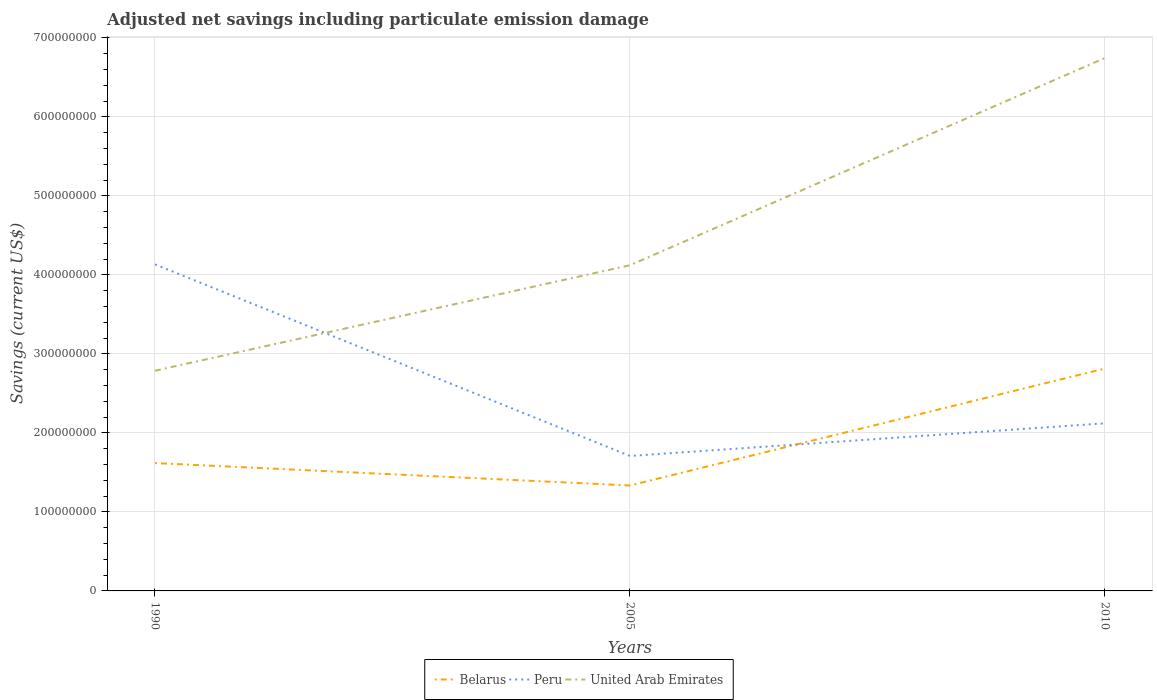How many different coloured lines are there?
Your answer should be compact. 3. Does the line corresponding to United Arab Emirates intersect with the line corresponding to Peru?
Ensure brevity in your answer.  Yes. Across all years, what is the maximum net savings in United Arab Emirates?
Ensure brevity in your answer.  2.79e+08. What is the total net savings in Belarus in the graph?
Offer a very short reply. 2.84e+07. What is the difference between the highest and the second highest net savings in Belarus?
Keep it short and to the point. 1.48e+08. What is the difference between the highest and the lowest net savings in United Arab Emirates?
Your answer should be compact. 1. Is the net savings in Belarus strictly greater than the net savings in Peru over the years?
Your answer should be compact. No. What is the difference between two consecutive major ticks on the Y-axis?
Offer a very short reply. 1.00e+08. Are the values on the major ticks of Y-axis written in scientific E-notation?
Ensure brevity in your answer.  No. Does the graph contain any zero values?
Ensure brevity in your answer.  No. How many legend labels are there?
Give a very brief answer. 3. How are the legend labels stacked?
Offer a very short reply. Horizontal. What is the title of the graph?
Offer a very short reply. Adjusted net savings including particulate emission damage. What is the label or title of the Y-axis?
Give a very brief answer. Savings (current US$). What is the Savings (current US$) in Belarus in 1990?
Your answer should be compact. 1.62e+08. What is the Savings (current US$) in Peru in 1990?
Make the answer very short. 4.13e+08. What is the Savings (current US$) of United Arab Emirates in 1990?
Provide a succinct answer. 2.79e+08. What is the Savings (current US$) in Belarus in 2005?
Ensure brevity in your answer.  1.33e+08. What is the Savings (current US$) in Peru in 2005?
Your response must be concise. 1.71e+08. What is the Savings (current US$) of United Arab Emirates in 2005?
Offer a terse response. 4.12e+08. What is the Savings (current US$) in Belarus in 2010?
Provide a succinct answer. 2.82e+08. What is the Savings (current US$) in Peru in 2010?
Your response must be concise. 2.12e+08. What is the Savings (current US$) in United Arab Emirates in 2010?
Provide a short and direct response. 6.75e+08. Across all years, what is the maximum Savings (current US$) of Belarus?
Ensure brevity in your answer.  2.82e+08. Across all years, what is the maximum Savings (current US$) in Peru?
Make the answer very short. 4.13e+08. Across all years, what is the maximum Savings (current US$) in United Arab Emirates?
Offer a terse response. 6.75e+08. Across all years, what is the minimum Savings (current US$) in Belarus?
Offer a terse response. 1.33e+08. Across all years, what is the minimum Savings (current US$) of Peru?
Your response must be concise. 1.71e+08. Across all years, what is the minimum Savings (current US$) in United Arab Emirates?
Keep it short and to the point. 2.79e+08. What is the total Savings (current US$) in Belarus in the graph?
Make the answer very short. 5.77e+08. What is the total Savings (current US$) of Peru in the graph?
Your response must be concise. 7.96e+08. What is the total Savings (current US$) of United Arab Emirates in the graph?
Offer a terse response. 1.37e+09. What is the difference between the Savings (current US$) in Belarus in 1990 and that in 2005?
Offer a very short reply. 2.84e+07. What is the difference between the Savings (current US$) in Peru in 1990 and that in 2005?
Your response must be concise. 2.43e+08. What is the difference between the Savings (current US$) of United Arab Emirates in 1990 and that in 2005?
Your answer should be very brief. -1.34e+08. What is the difference between the Savings (current US$) in Belarus in 1990 and that in 2010?
Ensure brevity in your answer.  -1.20e+08. What is the difference between the Savings (current US$) in Peru in 1990 and that in 2010?
Your response must be concise. 2.01e+08. What is the difference between the Savings (current US$) of United Arab Emirates in 1990 and that in 2010?
Your answer should be very brief. -3.96e+08. What is the difference between the Savings (current US$) in Belarus in 2005 and that in 2010?
Make the answer very short. -1.48e+08. What is the difference between the Savings (current US$) in Peru in 2005 and that in 2010?
Ensure brevity in your answer.  -4.13e+07. What is the difference between the Savings (current US$) in United Arab Emirates in 2005 and that in 2010?
Offer a very short reply. -2.62e+08. What is the difference between the Savings (current US$) in Belarus in 1990 and the Savings (current US$) in Peru in 2005?
Your answer should be very brief. -9.00e+06. What is the difference between the Savings (current US$) of Belarus in 1990 and the Savings (current US$) of United Arab Emirates in 2005?
Your answer should be compact. -2.50e+08. What is the difference between the Savings (current US$) in Peru in 1990 and the Savings (current US$) in United Arab Emirates in 2005?
Make the answer very short. 1.05e+06. What is the difference between the Savings (current US$) of Belarus in 1990 and the Savings (current US$) of Peru in 2010?
Provide a short and direct response. -5.03e+07. What is the difference between the Savings (current US$) of Belarus in 1990 and the Savings (current US$) of United Arab Emirates in 2010?
Make the answer very short. -5.13e+08. What is the difference between the Savings (current US$) in Peru in 1990 and the Savings (current US$) in United Arab Emirates in 2010?
Keep it short and to the point. -2.61e+08. What is the difference between the Savings (current US$) of Belarus in 2005 and the Savings (current US$) of Peru in 2010?
Your answer should be compact. -7.87e+07. What is the difference between the Savings (current US$) in Belarus in 2005 and the Savings (current US$) in United Arab Emirates in 2010?
Your answer should be compact. -5.41e+08. What is the difference between the Savings (current US$) in Peru in 2005 and the Savings (current US$) in United Arab Emirates in 2010?
Provide a succinct answer. -5.04e+08. What is the average Savings (current US$) of Belarus per year?
Offer a terse response. 1.92e+08. What is the average Savings (current US$) in Peru per year?
Make the answer very short. 2.65e+08. What is the average Savings (current US$) in United Arab Emirates per year?
Give a very brief answer. 4.55e+08. In the year 1990, what is the difference between the Savings (current US$) of Belarus and Savings (current US$) of Peru?
Offer a very short reply. -2.52e+08. In the year 1990, what is the difference between the Savings (current US$) in Belarus and Savings (current US$) in United Arab Emirates?
Make the answer very short. -1.17e+08. In the year 1990, what is the difference between the Savings (current US$) in Peru and Savings (current US$) in United Arab Emirates?
Your answer should be compact. 1.35e+08. In the year 2005, what is the difference between the Savings (current US$) of Belarus and Savings (current US$) of Peru?
Give a very brief answer. -3.74e+07. In the year 2005, what is the difference between the Savings (current US$) in Belarus and Savings (current US$) in United Arab Emirates?
Offer a very short reply. -2.79e+08. In the year 2005, what is the difference between the Savings (current US$) of Peru and Savings (current US$) of United Arab Emirates?
Offer a very short reply. -2.41e+08. In the year 2010, what is the difference between the Savings (current US$) in Belarus and Savings (current US$) in Peru?
Give a very brief answer. 6.93e+07. In the year 2010, what is the difference between the Savings (current US$) of Belarus and Savings (current US$) of United Arab Emirates?
Offer a very short reply. -3.93e+08. In the year 2010, what is the difference between the Savings (current US$) of Peru and Savings (current US$) of United Arab Emirates?
Provide a short and direct response. -4.62e+08. What is the ratio of the Savings (current US$) of Belarus in 1990 to that in 2005?
Ensure brevity in your answer.  1.21. What is the ratio of the Savings (current US$) of Peru in 1990 to that in 2005?
Your response must be concise. 2.42. What is the ratio of the Savings (current US$) of United Arab Emirates in 1990 to that in 2005?
Give a very brief answer. 0.68. What is the ratio of the Savings (current US$) in Belarus in 1990 to that in 2010?
Provide a succinct answer. 0.57. What is the ratio of the Savings (current US$) in Peru in 1990 to that in 2010?
Your answer should be compact. 1.95. What is the ratio of the Savings (current US$) in United Arab Emirates in 1990 to that in 2010?
Offer a terse response. 0.41. What is the ratio of the Savings (current US$) in Belarus in 2005 to that in 2010?
Give a very brief answer. 0.47. What is the ratio of the Savings (current US$) in Peru in 2005 to that in 2010?
Ensure brevity in your answer.  0.81. What is the ratio of the Savings (current US$) of United Arab Emirates in 2005 to that in 2010?
Provide a short and direct response. 0.61. What is the difference between the highest and the second highest Savings (current US$) of Belarus?
Provide a short and direct response. 1.20e+08. What is the difference between the highest and the second highest Savings (current US$) of Peru?
Provide a short and direct response. 2.01e+08. What is the difference between the highest and the second highest Savings (current US$) in United Arab Emirates?
Offer a terse response. 2.62e+08. What is the difference between the highest and the lowest Savings (current US$) in Belarus?
Ensure brevity in your answer.  1.48e+08. What is the difference between the highest and the lowest Savings (current US$) in Peru?
Provide a succinct answer. 2.43e+08. What is the difference between the highest and the lowest Savings (current US$) in United Arab Emirates?
Give a very brief answer. 3.96e+08. 